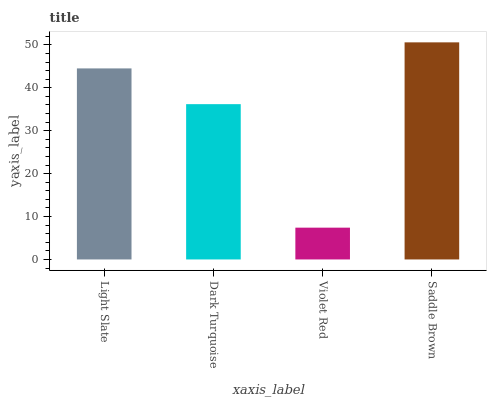Is Violet Red the minimum?
Answer yes or no. Yes. Is Saddle Brown the maximum?
Answer yes or no. Yes. Is Dark Turquoise the minimum?
Answer yes or no. No. Is Dark Turquoise the maximum?
Answer yes or no. No. Is Light Slate greater than Dark Turquoise?
Answer yes or no. Yes. Is Dark Turquoise less than Light Slate?
Answer yes or no. Yes. Is Dark Turquoise greater than Light Slate?
Answer yes or no. No. Is Light Slate less than Dark Turquoise?
Answer yes or no. No. Is Light Slate the high median?
Answer yes or no. Yes. Is Dark Turquoise the low median?
Answer yes or no. Yes. Is Dark Turquoise the high median?
Answer yes or no. No. Is Saddle Brown the low median?
Answer yes or no. No. 